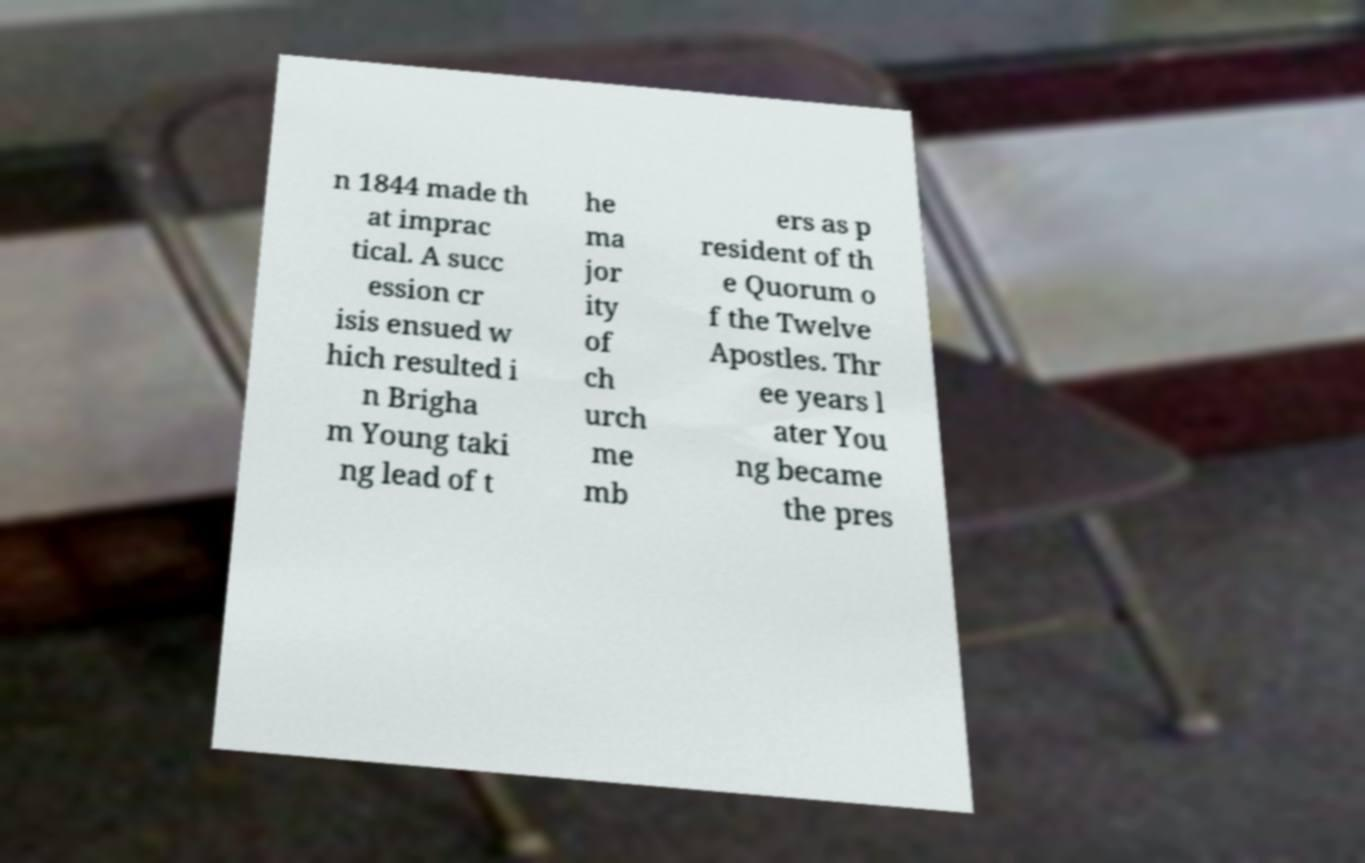Please read and relay the text visible in this image. What does it say? n 1844 made th at imprac tical. A succ ession cr isis ensued w hich resulted i n Brigha m Young taki ng lead of t he ma jor ity of ch urch me mb ers as p resident of th e Quorum o f the Twelve Apostles. Thr ee years l ater You ng became the pres 